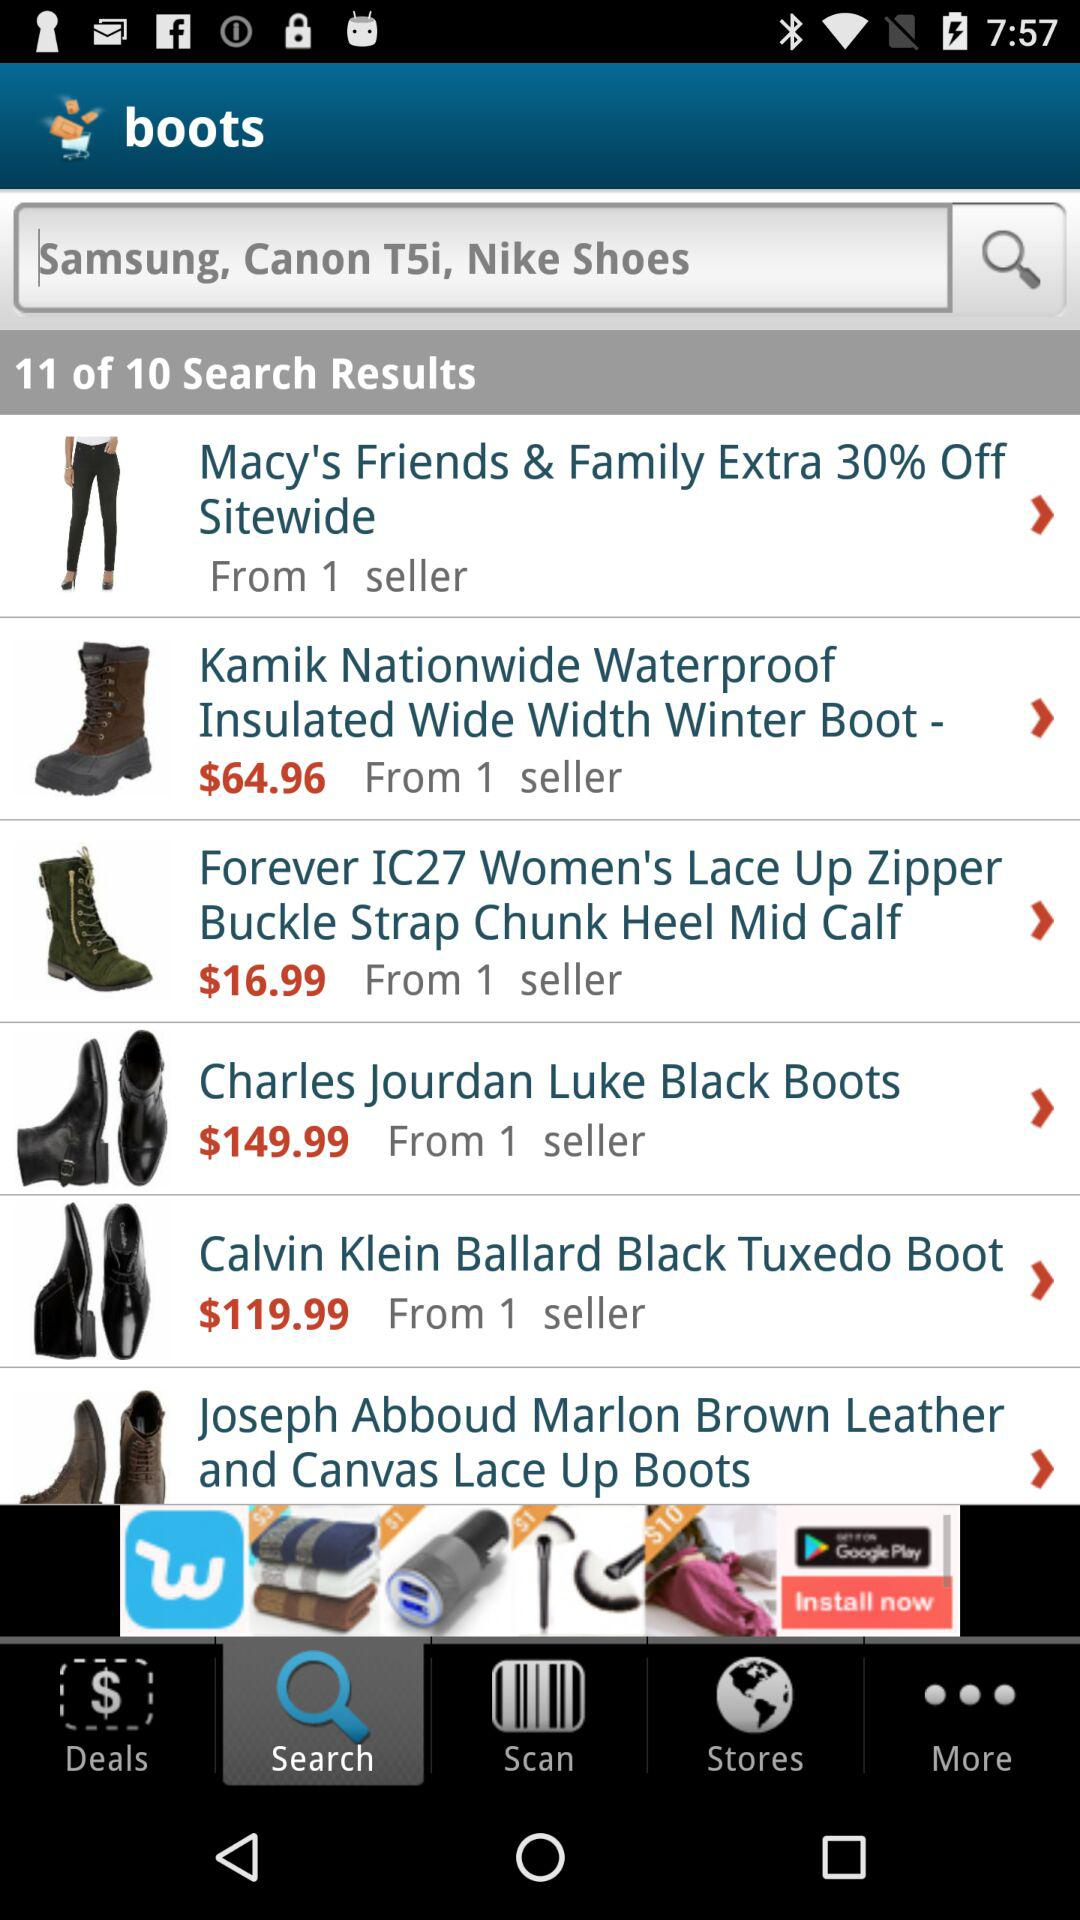What item has a price of $119.99? The item is a Calvin Klein Ballard Black Tuxedo Boot. 